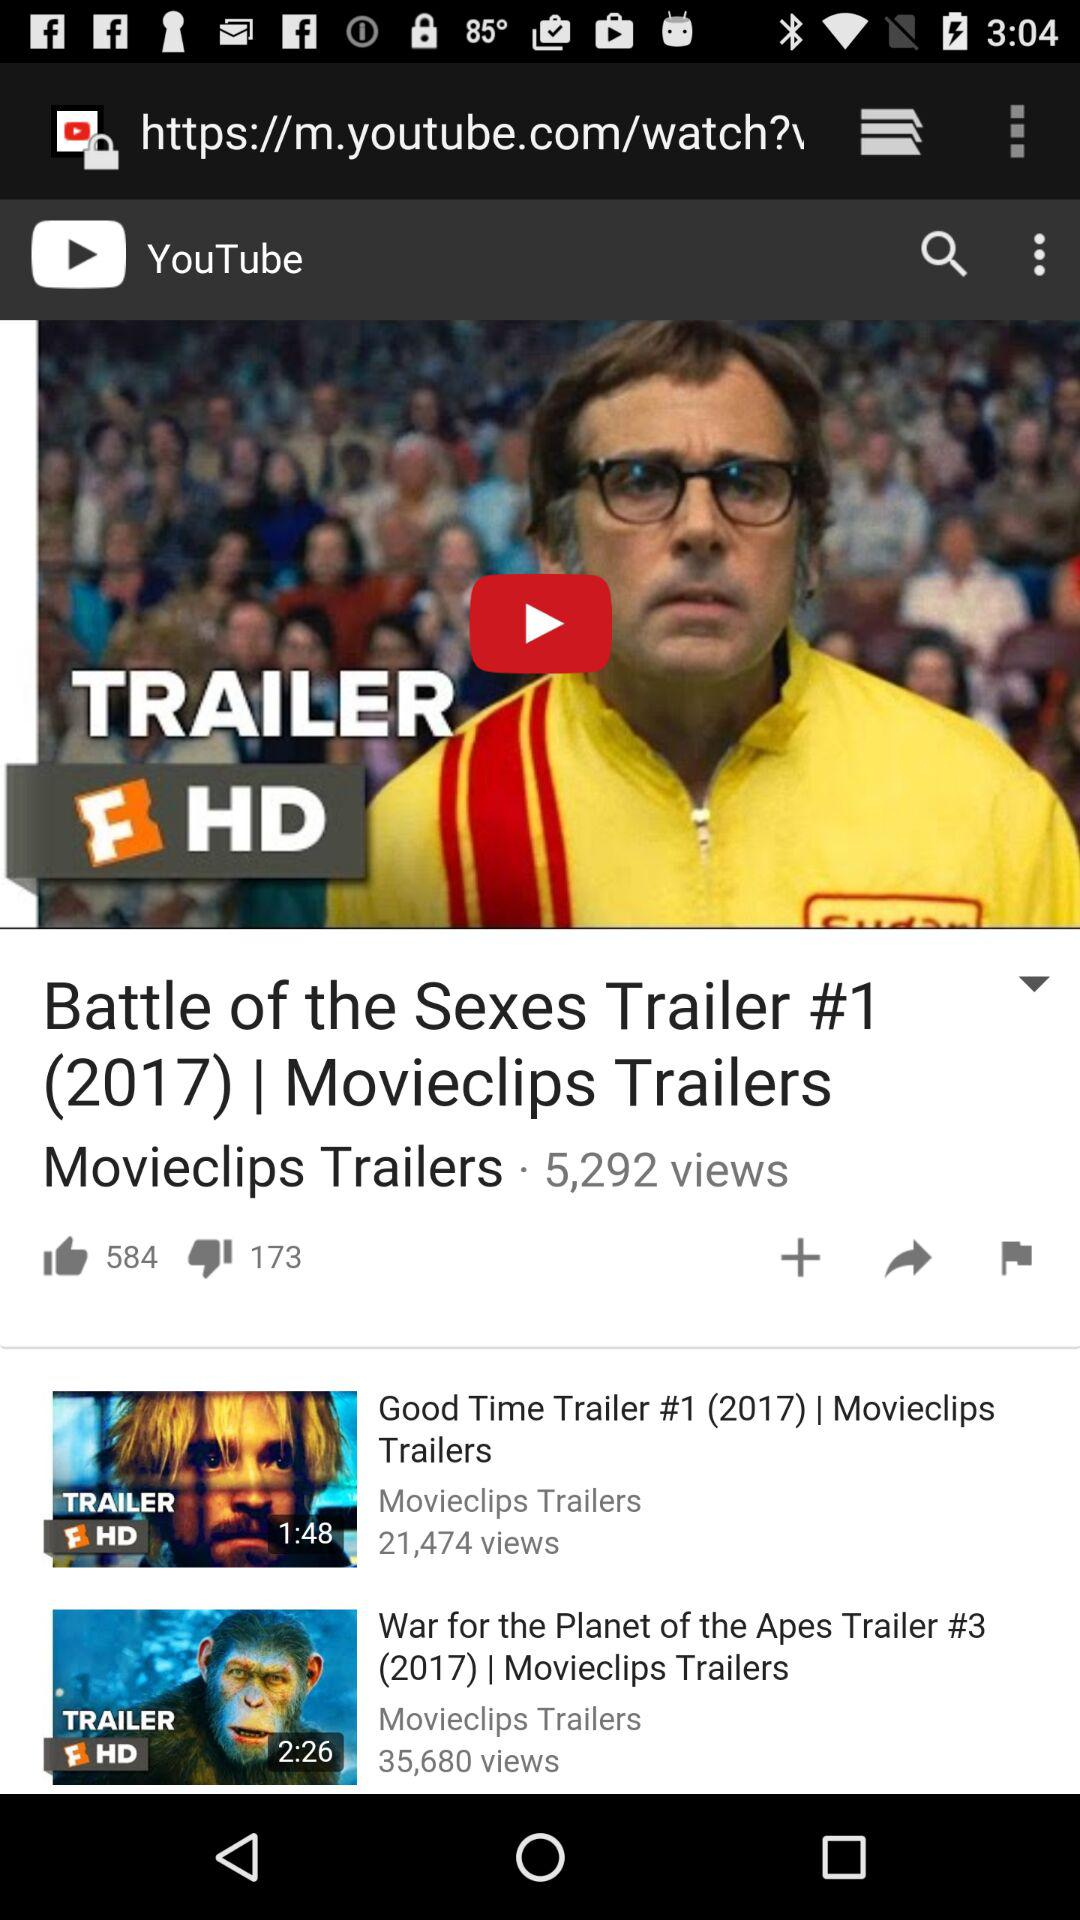How many dislikes did the video get? The video got 173 dislikes. 